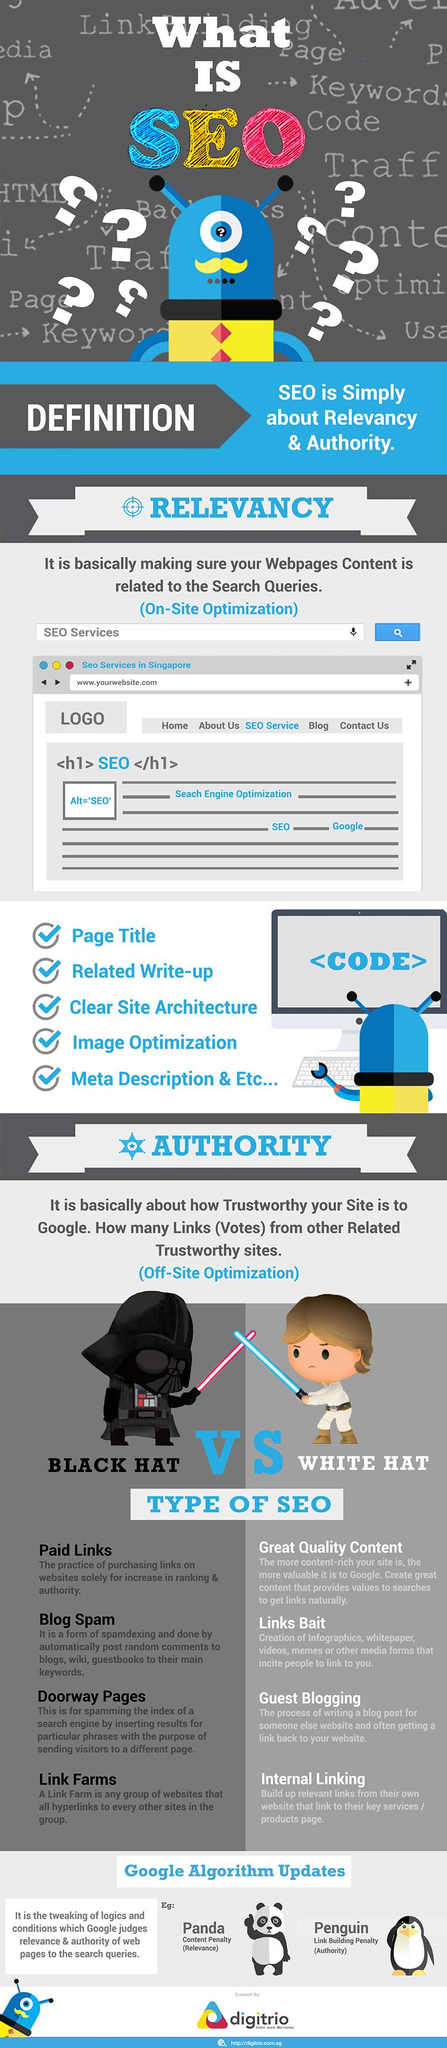Give some essential details in this illustration. Guest blogging is a type of SEO that adheres to white hat practices. The color of the sword held by the black figure is red. Clear site architecture is the third checkpoint in relevancy. There are two types of SEO. Doorway pages are used to spam the index of a search engine. 